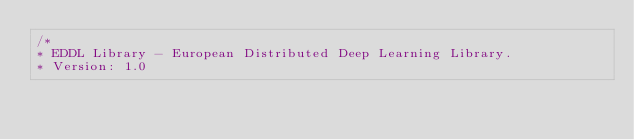Convert code to text. <code><loc_0><loc_0><loc_500><loc_500><_Cuda_>/*
* EDDL Library - European Distributed Deep Learning Library.
* Version: 1.0</code> 